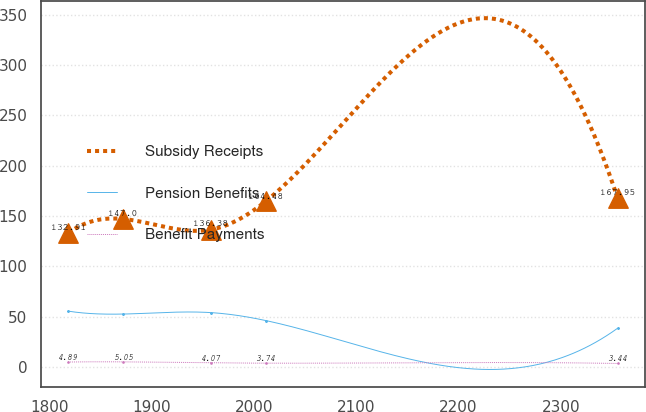Convert chart. <chart><loc_0><loc_0><loc_500><loc_500><line_chart><ecel><fcel>Subsidy Receipts<fcel>Pension Benefits<fcel>Benefit Payments<nl><fcel>1818.11<fcel>132.91<fcel>55.45<fcel>4.89<nl><fcel>1871.85<fcel>147<fcel>52.55<fcel>5.05<nl><fcel>1957.49<fcel>136.38<fcel>54<fcel>4.07<nl><fcel>2011.23<fcel>164.48<fcel>46.13<fcel>3.74<nl><fcel>2355.53<fcel>167.95<fcel>38.4<fcel>3.44<nl></chart> 